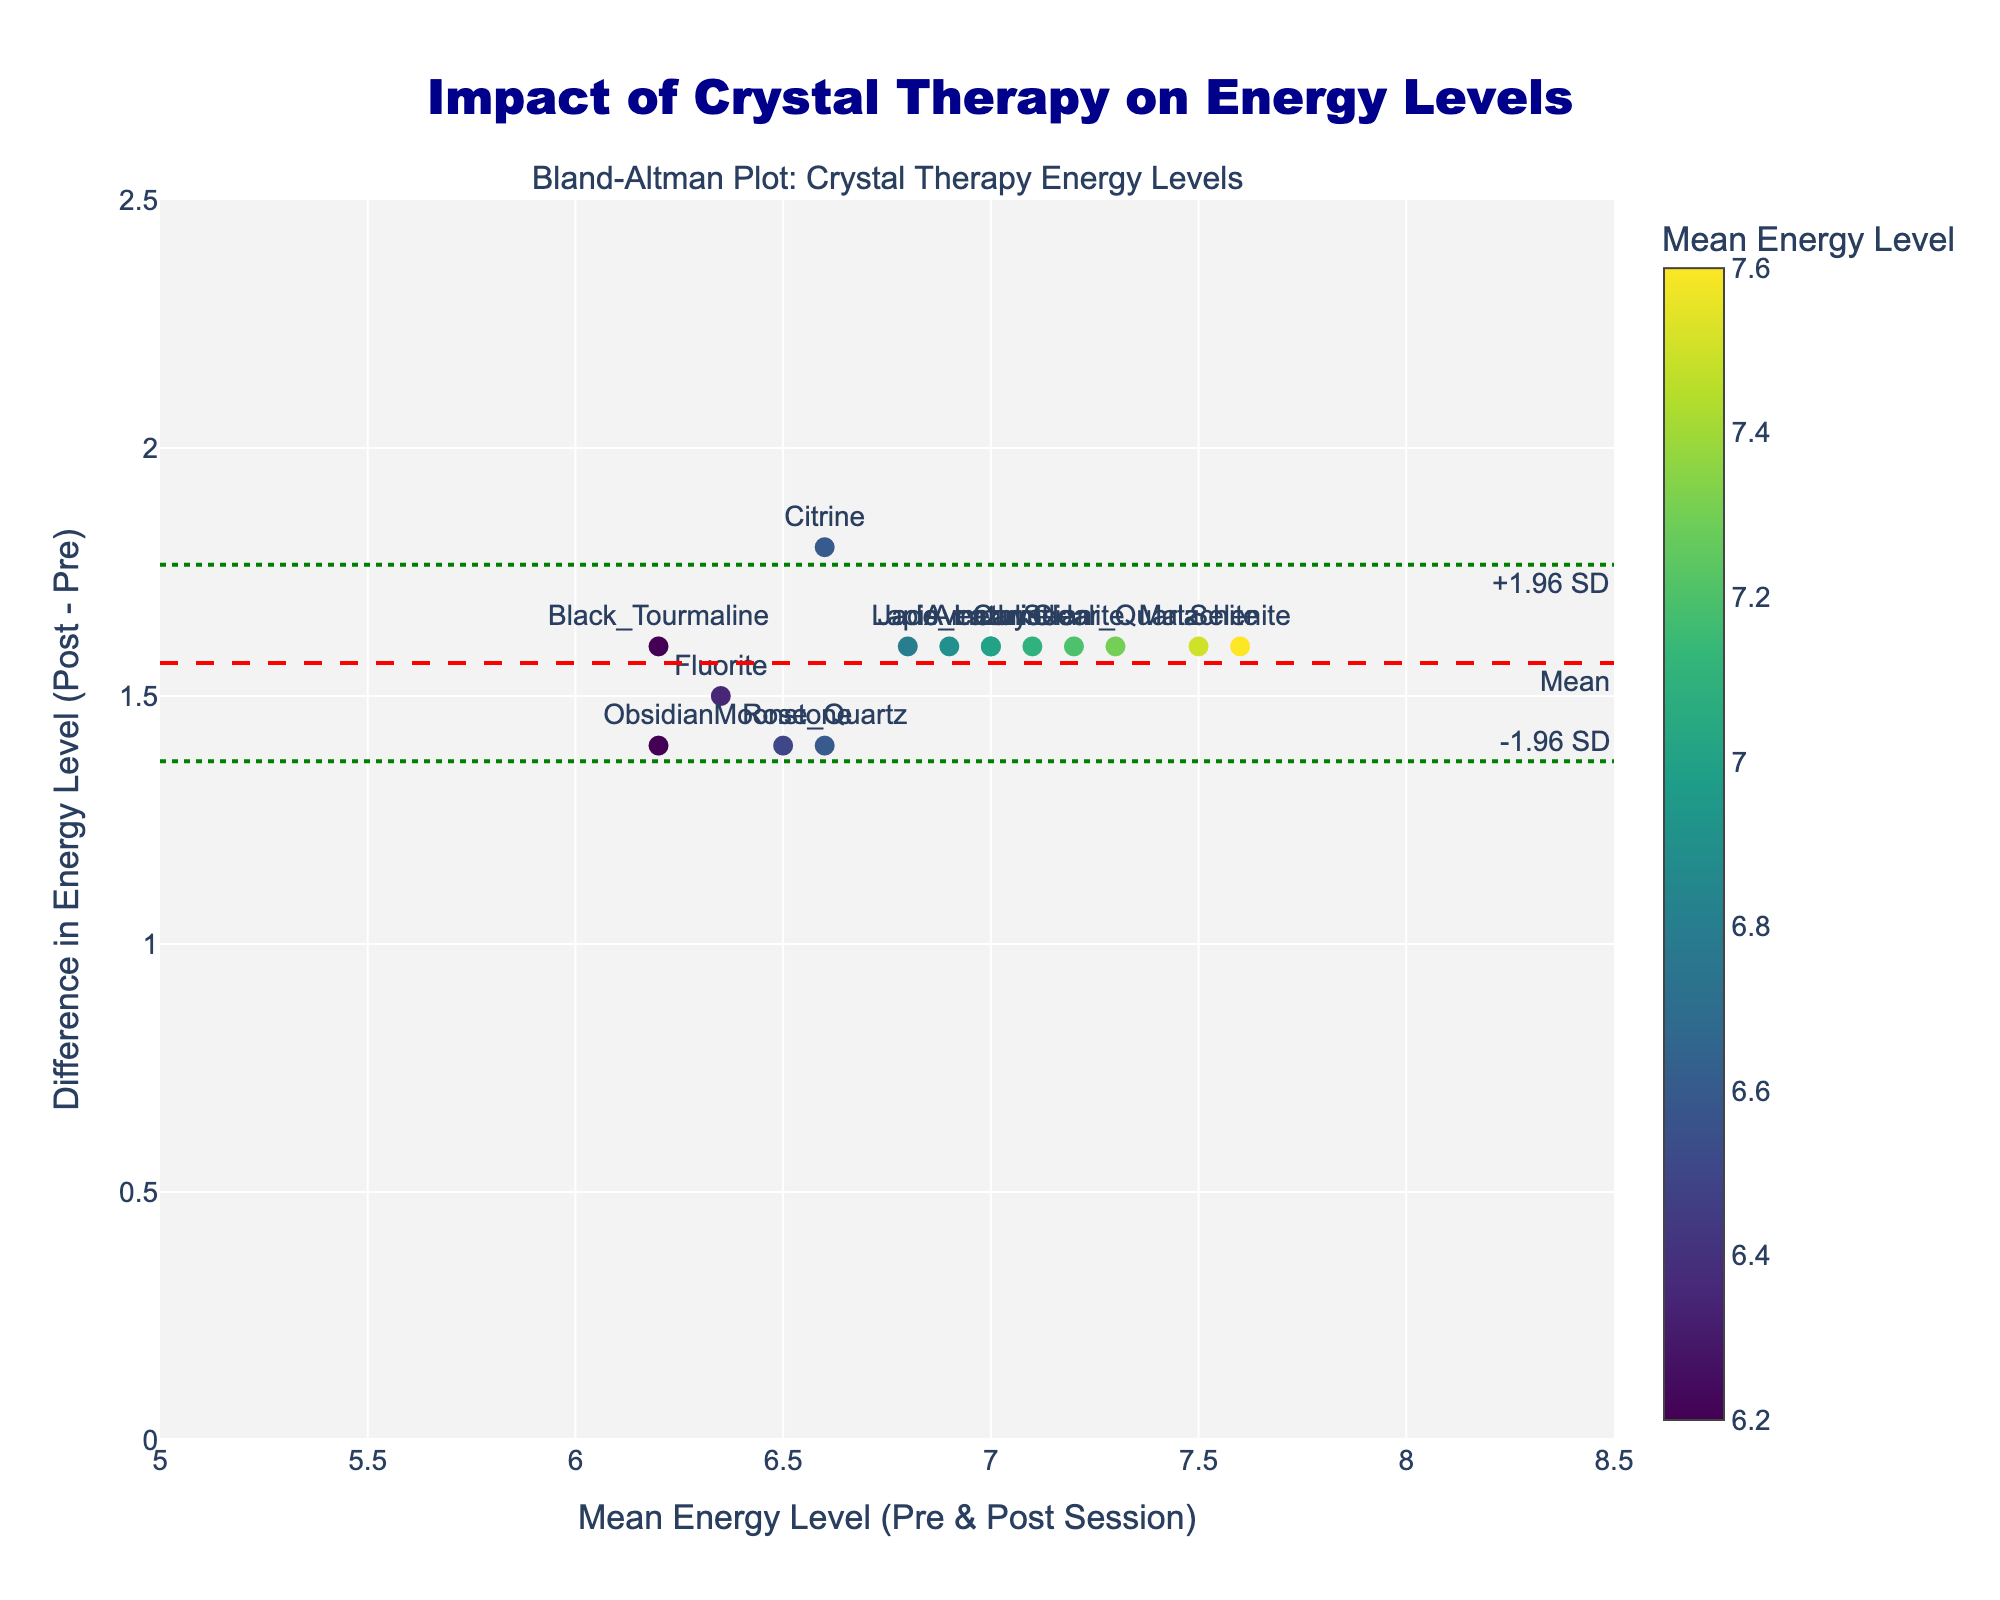What is the title of the plot? The title of the plot is located at the top center of the figure. It reads "Impact of Crystal Therapy on Energy Levels".
Answer: Impact of Crystal Therapy on Energy Levels How many different types of crystals are represented in the plot? Each marker on the plot represents a different type of crystal. By counting the distinct markers, there are 15 different types of crystals.
Answer: 15 Which crystal type corresponds to the highest mean energy level? Hovering over each marker or checking the color scale helps identify the crystal type with the highest mean energy level. "Selenite" has the highest mean energy level just over 7.6.
Answer: Selenite What are the lower and upper limits of agreement (LOA)? The plot has two green dotted lines indicating the LOA. They are labeled on the y-axis as "+1.96 SD" and "-1.96 SD". The lower LOA is approximately 0.6, and the upper LOA is approximately 1.9.
Answer: 0.6 and 1.9 What does the mean difference line represent in the plot, and where is it located? The mean difference line is a red dashed line that runs horizontally across the plot. It represents the mean difference in energy levels between pre and post-sessions, located approximately at 1.5 on the y-axis.
Answer: Mean difference at 1.5 Which crystal has the smallest difference in energy levels between pre and post sessions? By examining the vertical position of the markers (difference axis), "Black Tourmaline" shows the smallest difference in energy levels, close to exactly 1.5.
Answer: Black Tourmaline Which crystal has the greatest variation in energy levels between pre and post sessions? Comparing the vertical distances of the markers from the mean line helps identify "Selenite" as the crystal with the greatest variation, with a difference around 1.6.
Answer: Selenite Is there any crystal type that lies outside the limits of agreement? Checking the positions of all markers, there are no crystals that lie outside the green dotted lines, indicating all differences fall within the LOA.
Answer: No What is the average mean energy level across all crystal types? The mean energy level can be approximated from the x-axis values, ranging from 5.6 to 7.8, with a rough average around 6.7-6.8. Summing the means and dividing by number of crystals, (6.2+5.9+6.5+5.7+6.8+5.4+6.1+5.8+6.3+6.0+5.6+6.4+5.5+6.7+6.2)/15 gives an average.
Answer: Approximately 6.3 